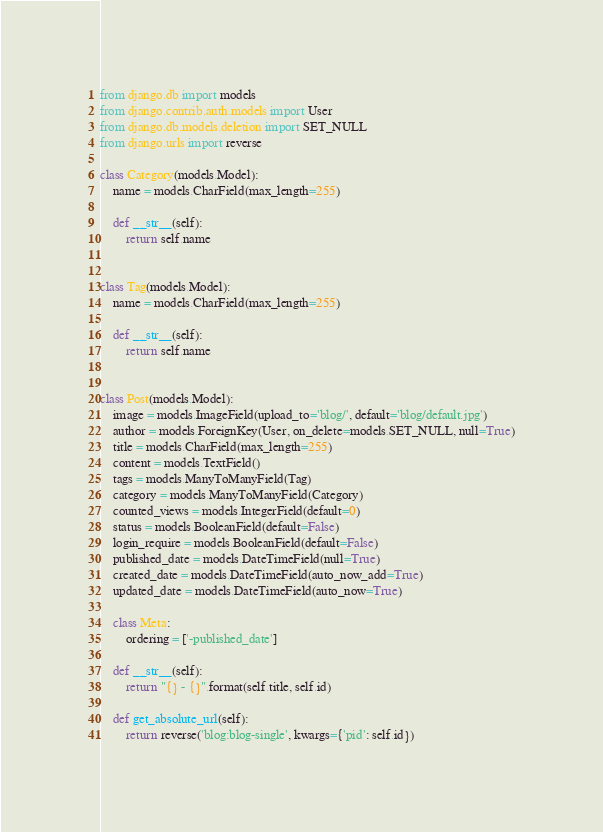<code> <loc_0><loc_0><loc_500><loc_500><_Python_>from django.db import models
from django.contrib.auth.models import User
from django.db.models.deletion import SET_NULL
from django.urls import reverse

class Category(models.Model):
    name = models.CharField(max_length=255)

    def __str__(self):
        return self.name


class Tag(models.Model):
    name = models.CharField(max_length=255)

    def __str__(self):
        return self.name    


class Post(models.Model):
    image = models.ImageField(upload_to='blog/', default='blog/default.jpg')
    author = models.ForeignKey(User, on_delete=models.SET_NULL, null=True)
    title = models.CharField(max_length=255)
    content = models.TextField()
    tags = models.ManyToManyField(Tag)
    category = models.ManyToManyField(Category) 
    counted_views = models.IntegerField(default=0)
    status = models.BooleanField(default=False)
    login_require = models.BooleanField(default=False)
    published_date = models.DateTimeField(null=True)
    created_date = models.DateTimeField(auto_now_add=True)
    updated_date = models.DateTimeField(auto_now=True)

    class Meta:
        ordering = ['-published_date']

    def __str__(self):
        return "{} - {}".format(self.title, self.id)

    def get_absolute_url(self):
        return reverse('blog:blog-single', kwargs={'pid': self.id})</code> 